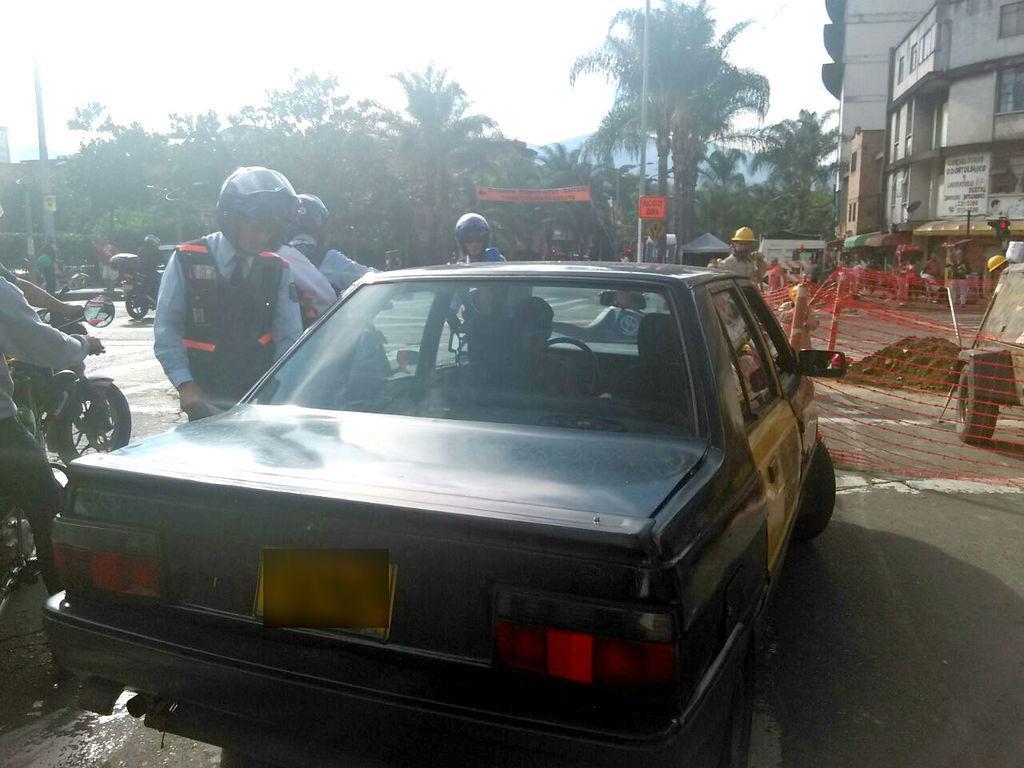In one or two sentences, can you explain what this image depicts? In this image we can see a car placed on the road. We can also see a group of people wearing helmets and some people riding motor bikes. On the right side we can see the net with some poles, a heap of mud and a vehicle. On the backside we can see a building with windows and a signboard, a banner with some text on it, a group of trees, poles, the hill and the sky which looks cloudy. 